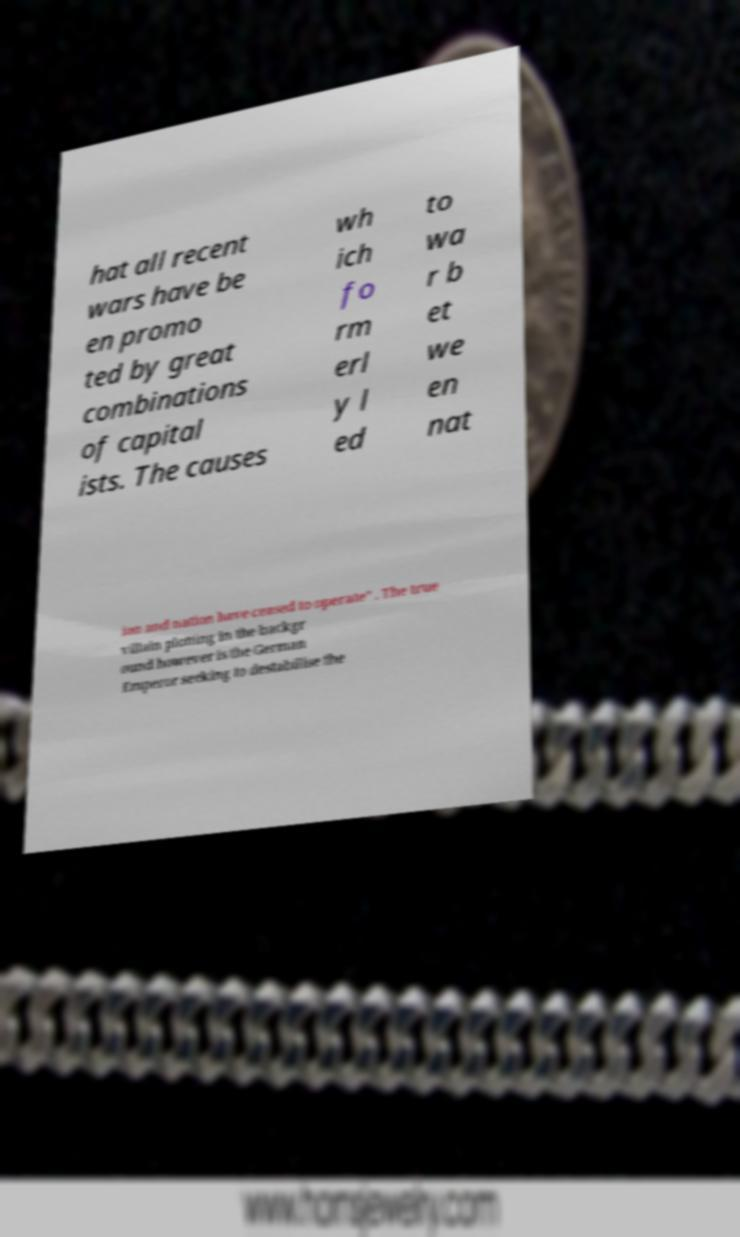Could you assist in decoding the text presented in this image and type it out clearly? hat all recent wars have be en promo ted by great combinations of capital ists. The causes wh ich fo rm erl y l ed to wa r b et we en nat ion and nation have ceased to operate" . The true villain plotting in the backgr ound however is the German Emperor seeking to destabilise the 